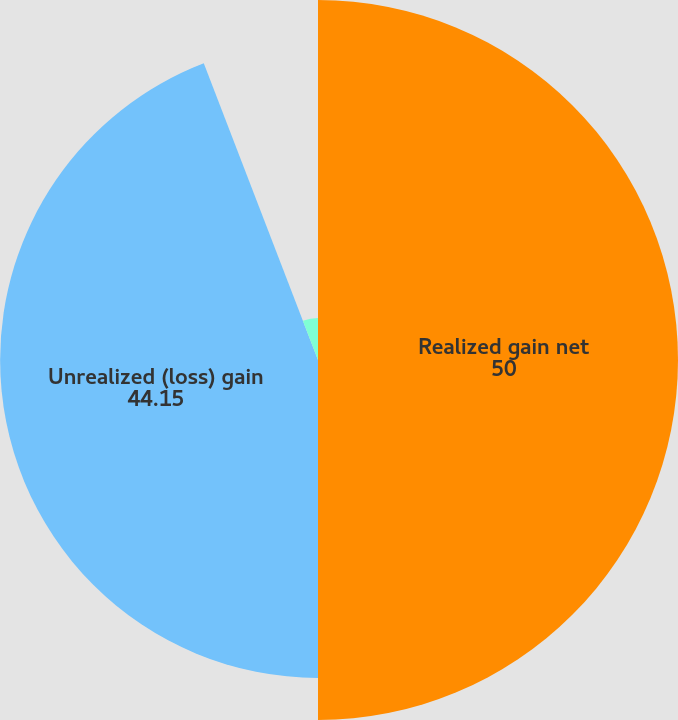Convert chart to OTSL. <chart><loc_0><loc_0><loc_500><loc_500><pie_chart><fcel>Realized gain net<fcel>Unrealized (loss) gain<fcel>Total translated earnings<nl><fcel>50.0%<fcel>44.15%<fcel>5.85%<nl></chart> 